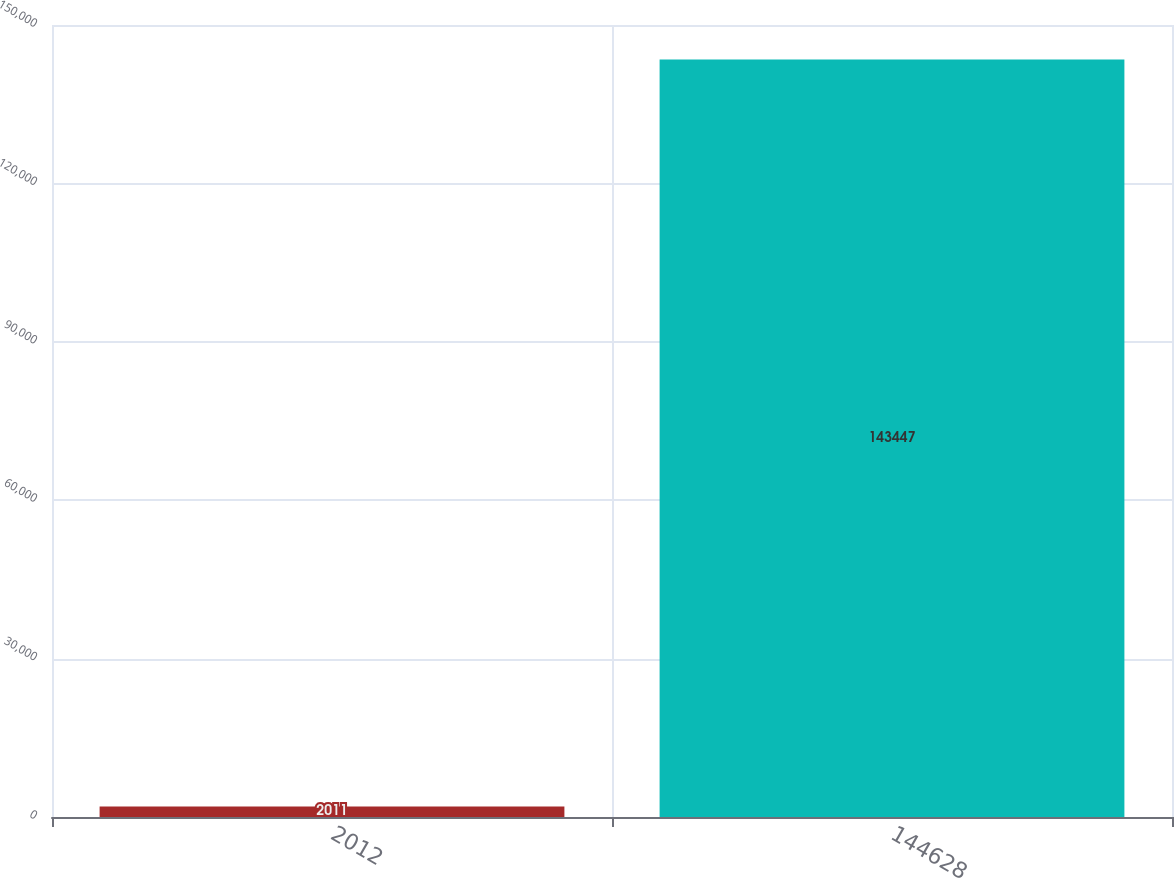Convert chart to OTSL. <chart><loc_0><loc_0><loc_500><loc_500><bar_chart><fcel>2012<fcel>144628<nl><fcel>2011<fcel>143447<nl></chart> 